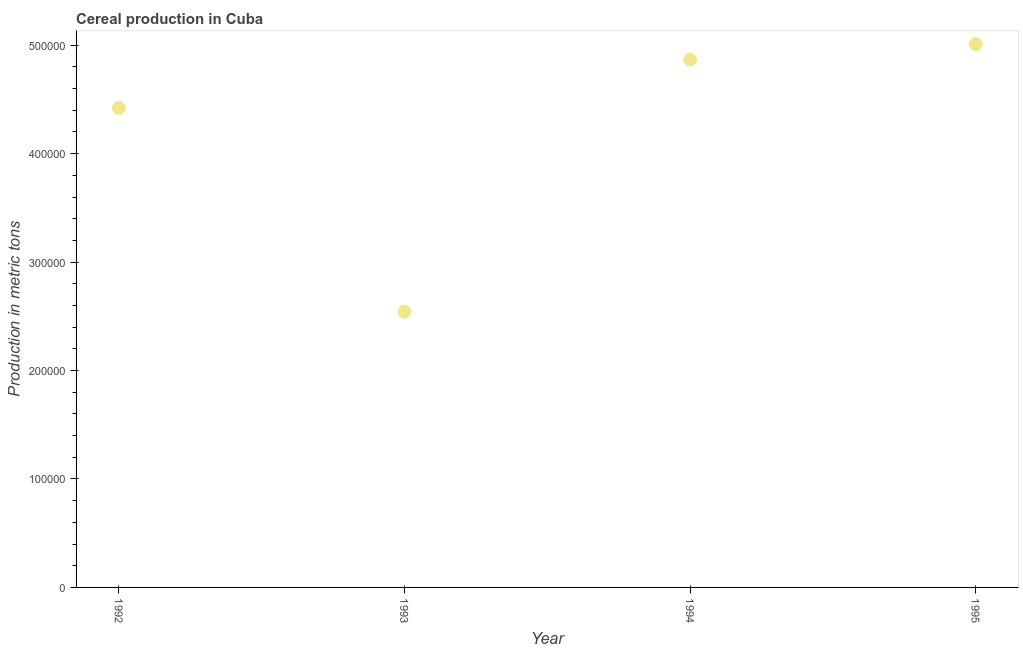What is the cereal production in 1993?
Offer a very short reply. 2.54e+05. Across all years, what is the maximum cereal production?
Give a very brief answer. 5.01e+05. Across all years, what is the minimum cereal production?
Your answer should be very brief. 2.54e+05. In which year was the cereal production maximum?
Your answer should be compact. 1995. What is the sum of the cereal production?
Offer a very short reply. 1.68e+06. What is the difference between the cereal production in 1993 and 1995?
Provide a succinct answer. -2.47e+05. What is the average cereal production per year?
Provide a succinct answer. 4.21e+05. What is the median cereal production?
Your answer should be very brief. 4.64e+05. Do a majority of the years between 1992 and 1993 (inclusive) have cereal production greater than 240000 metric tons?
Ensure brevity in your answer.  Yes. What is the ratio of the cereal production in 1993 to that in 1994?
Offer a very short reply. 0.52. Is the cereal production in 1993 less than that in 1994?
Your answer should be very brief. Yes. What is the difference between the highest and the second highest cereal production?
Provide a short and direct response. 1.42e+04. Is the sum of the cereal production in 1992 and 1995 greater than the maximum cereal production across all years?
Ensure brevity in your answer.  Yes. What is the difference between the highest and the lowest cereal production?
Offer a terse response. 2.47e+05. In how many years, is the cereal production greater than the average cereal production taken over all years?
Keep it short and to the point. 3. Does the cereal production monotonically increase over the years?
Offer a terse response. No. How many years are there in the graph?
Provide a succinct answer. 4. What is the difference between two consecutive major ticks on the Y-axis?
Offer a very short reply. 1.00e+05. Are the values on the major ticks of Y-axis written in scientific E-notation?
Provide a short and direct response. No. Does the graph contain any zero values?
Provide a short and direct response. No. Does the graph contain grids?
Give a very brief answer. No. What is the title of the graph?
Keep it short and to the point. Cereal production in Cuba. What is the label or title of the X-axis?
Ensure brevity in your answer.  Year. What is the label or title of the Y-axis?
Ensure brevity in your answer.  Production in metric tons. What is the Production in metric tons in 1992?
Provide a succinct answer. 4.42e+05. What is the Production in metric tons in 1993?
Ensure brevity in your answer.  2.54e+05. What is the Production in metric tons in 1994?
Keep it short and to the point. 4.87e+05. What is the Production in metric tons in 1995?
Provide a short and direct response. 5.01e+05. What is the difference between the Production in metric tons in 1992 and 1993?
Your response must be concise. 1.88e+05. What is the difference between the Production in metric tons in 1992 and 1994?
Offer a very short reply. -4.46e+04. What is the difference between the Production in metric tons in 1992 and 1995?
Offer a terse response. -5.88e+04. What is the difference between the Production in metric tons in 1993 and 1994?
Your response must be concise. -2.32e+05. What is the difference between the Production in metric tons in 1993 and 1995?
Your response must be concise. -2.47e+05. What is the difference between the Production in metric tons in 1994 and 1995?
Provide a short and direct response. -1.42e+04. What is the ratio of the Production in metric tons in 1992 to that in 1993?
Your response must be concise. 1.74. What is the ratio of the Production in metric tons in 1992 to that in 1994?
Keep it short and to the point. 0.91. What is the ratio of the Production in metric tons in 1992 to that in 1995?
Make the answer very short. 0.88. What is the ratio of the Production in metric tons in 1993 to that in 1994?
Provide a succinct answer. 0.52. What is the ratio of the Production in metric tons in 1993 to that in 1995?
Offer a very short reply. 0.51. 